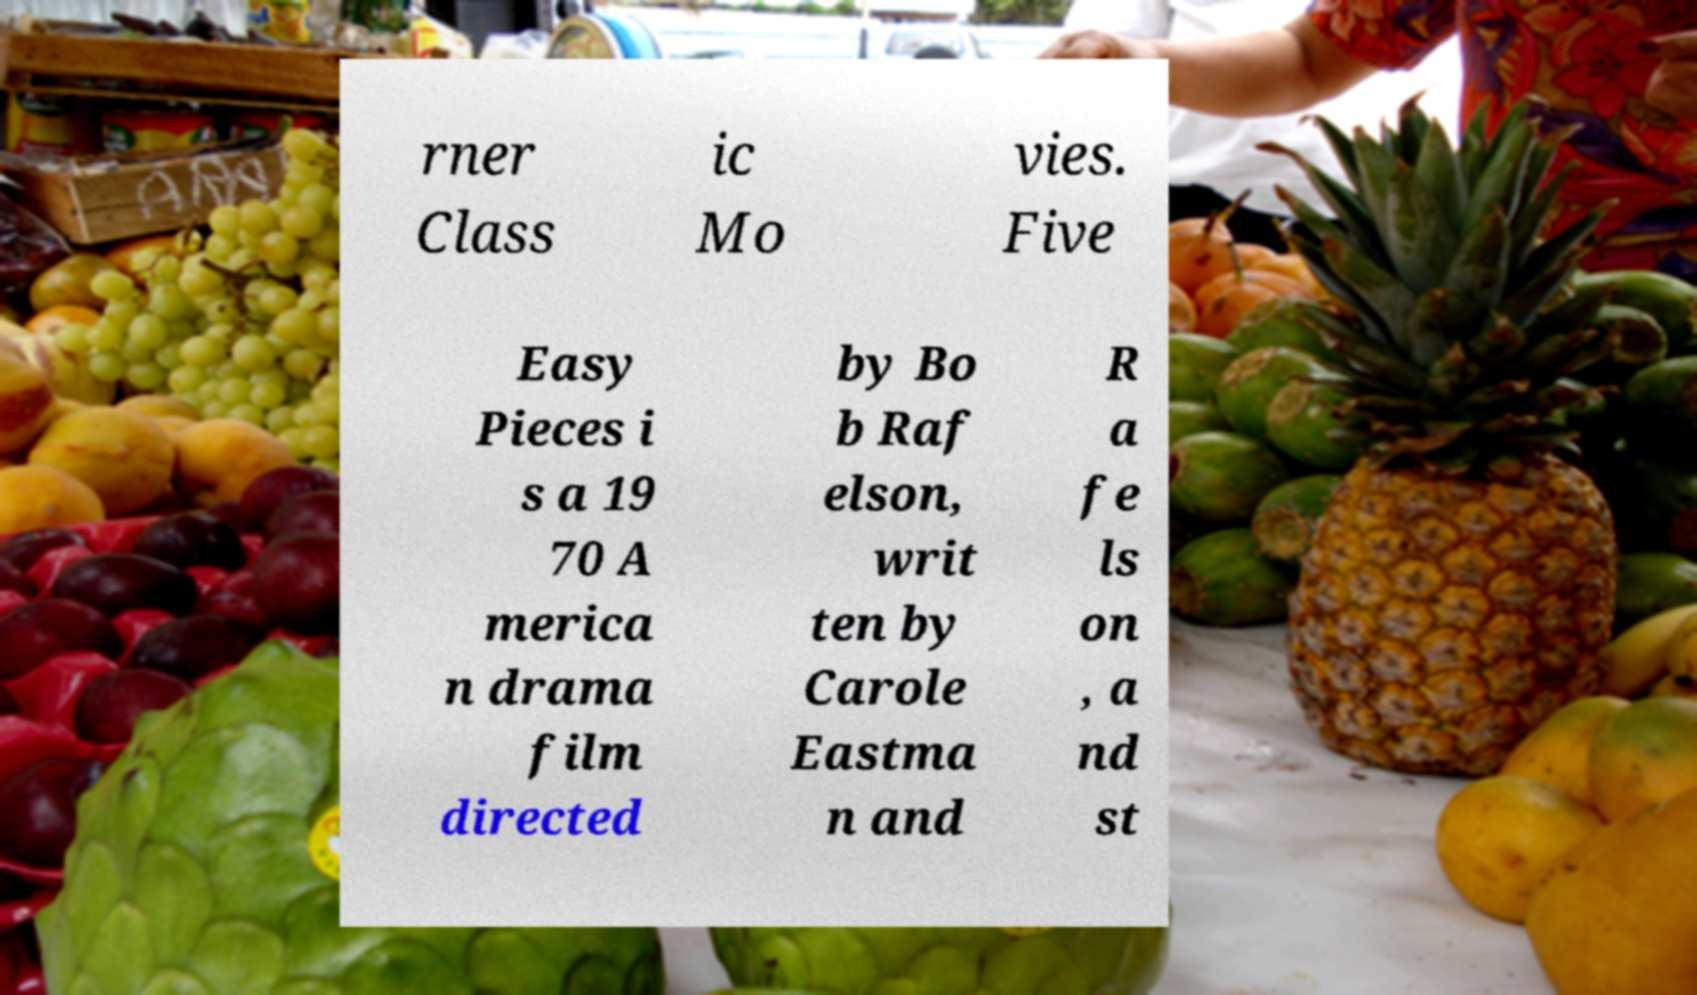Please identify and transcribe the text found in this image. rner Class ic Mo vies. Five Easy Pieces i s a 19 70 A merica n drama film directed by Bo b Raf elson, writ ten by Carole Eastma n and R a fe ls on , a nd st 